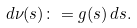<formula> <loc_0><loc_0><loc_500><loc_500>d \nu ( s ) \colon = g ( s ) \, d s .</formula> 